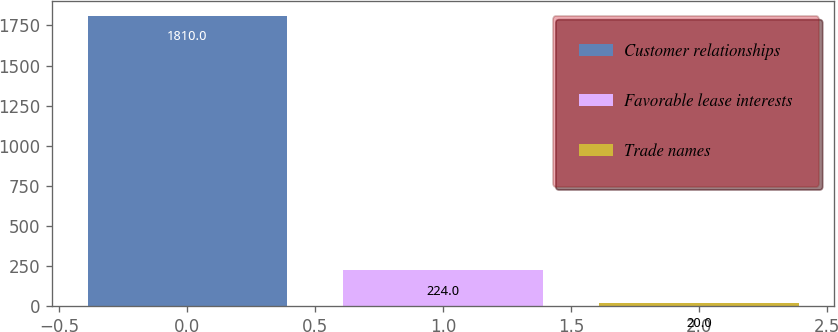<chart> <loc_0><loc_0><loc_500><loc_500><bar_chart><fcel>Customer relationships<fcel>Favorable lease interests<fcel>Trade names<nl><fcel>1810<fcel>224<fcel>20<nl></chart> 